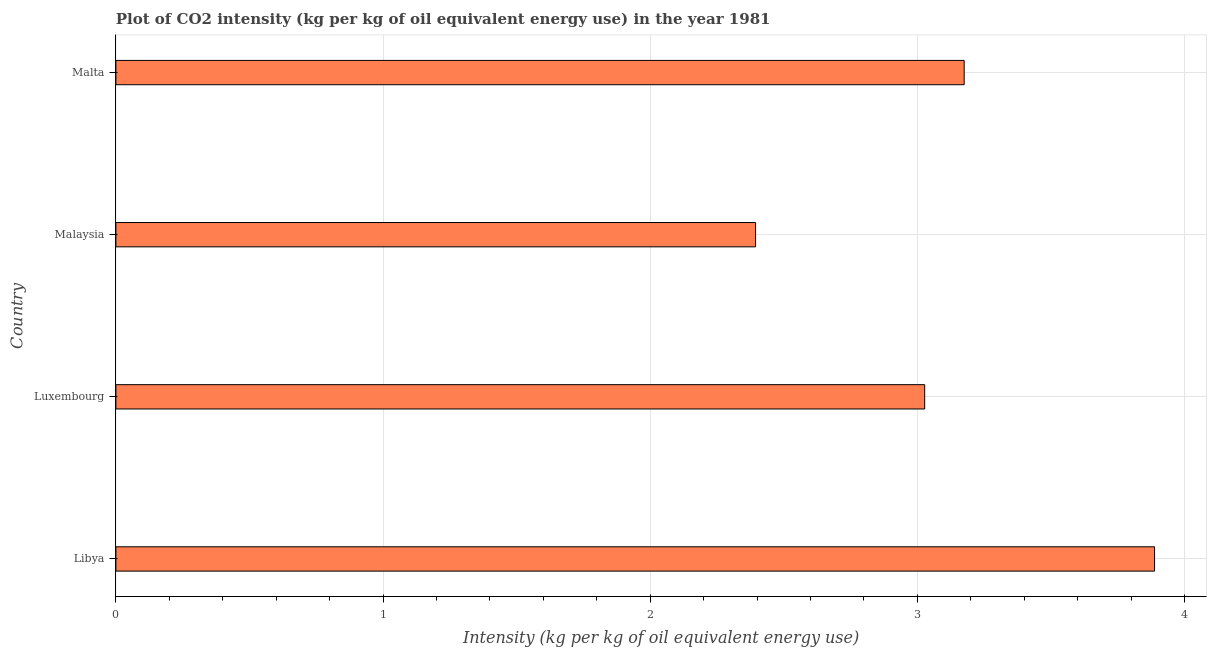What is the title of the graph?
Offer a very short reply. Plot of CO2 intensity (kg per kg of oil equivalent energy use) in the year 1981. What is the label or title of the X-axis?
Provide a succinct answer. Intensity (kg per kg of oil equivalent energy use). What is the co2 intensity in Malta?
Offer a terse response. 3.18. Across all countries, what is the maximum co2 intensity?
Keep it short and to the point. 3.89. Across all countries, what is the minimum co2 intensity?
Ensure brevity in your answer.  2.39. In which country was the co2 intensity maximum?
Your response must be concise. Libya. In which country was the co2 intensity minimum?
Your answer should be very brief. Malaysia. What is the sum of the co2 intensity?
Give a very brief answer. 12.49. What is the difference between the co2 intensity in Malaysia and Malta?
Make the answer very short. -0.78. What is the average co2 intensity per country?
Give a very brief answer. 3.12. What is the median co2 intensity?
Give a very brief answer. 3.1. What is the ratio of the co2 intensity in Luxembourg to that in Malaysia?
Your response must be concise. 1.26. Is the difference between the co2 intensity in Luxembourg and Malaysia greater than the difference between any two countries?
Offer a terse response. No. What is the difference between the highest and the second highest co2 intensity?
Your answer should be compact. 0.71. What is the difference between the highest and the lowest co2 intensity?
Provide a succinct answer. 1.49. In how many countries, is the co2 intensity greater than the average co2 intensity taken over all countries?
Keep it short and to the point. 2. How many bars are there?
Provide a short and direct response. 4. Are all the bars in the graph horizontal?
Ensure brevity in your answer.  Yes. What is the Intensity (kg per kg of oil equivalent energy use) of Libya?
Give a very brief answer. 3.89. What is the Intensity (kg per kg of oil equivalent energy use) of Luxembourg?
Make the answer very short. 3.03. What is the Intensity (kg per kg of oil equivalent energy use) in Malaysia?
Make the answer very short. 2.39. What is the Intensity (kg per kg of oil equivalent energy use) in Malta?
Give a very brief answer. 3.18. What is the difference between the Intensity (kg per kg of oil equivalent energy use) in Libya and Luxembourg?
Make the answer very short. 0.86. What is the difference between the Intensity (kg per kg of oil equivalent energy use) in Libya and Malaysia?
Ensure brevity in your answer.  1.49. What is the difference between the Intensity (kg per kg of oil equivalent energy use) in Libya and Malta?
Your answer should be very brief. 0.71. What is the difference between the Intensity (kg per kg of oil equivalent energy use) in Luxembourg and Malaysia?
Ensure brevity in your answer.  0.63. What is the difference between the Intensity (kg per kg of oil equivalent energy use) in Luxembourg and Malta?
Ensure brevity in your answer.  -0.15. What is the difference between the Intensity (kg per kg of oil equivalent energy use) in Malaysia and Malta?
Ensure brevity in your answer.  -0.78. What is the ratio of the Intensity (kg per kg of oil equivalent energy use) in Libya to that in Luxembourg?
Your answer should be compact. 1.28. What is the ratio of the Intensity (kg per kg of oil equivalent energy use) in Libya to that in Malaysia?
Offer a terse response. 1.62. What is the ratio of the Intensity (kg per kg of oil equivalent energy use) in Libya to that in Malta?
Your answer should be very brief. 1.22. What is the ratio of the Intensity (kg per kg of oil equivalent energy use) in Luxembourg to that in Malaysia?
Keep it short and to the point. 1.26. What is the ratio of the Intensity (kg per kg of oil equivalent energy use) in Luxembourg to that in Malta?
Ensure brevity in your answer.  0.95. What is the ratio of the Intensity (kg per kg of oil equivalent energy use) in Malaysia to that in Malta?
Provide a succinct answer. 0.75. 